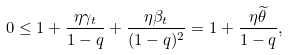Convert formula to latex. <formula><loc_0><loc_0><loc_500><loc_500>0 \leq 1 + \frac { \eta \gamma _ { t } } { 1 - q } + \frac { \eta \beta _ { t } } { ( 1 - q ) ^ { 2 } } = 1 + \frac { \eta \widetilde { \theta } } { 1 - q } ,</formula> 